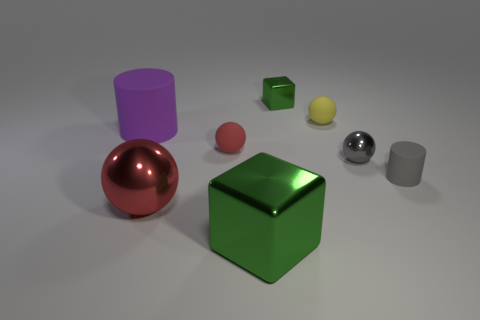Add 1 big red spheres. How many objects exist? 9 Subtract all cubes. How many objects are left? 6 Subtract 1 red spheres. How many objects are left? 7 Subtract all big rubber cylinders. Subtract all green metal cubes. How many objects are left? 5 Add 7 small yellow objects. How many small yellow objects are left? 8 Add 8 large purple matte spheres. How many large purple matte spheres exist? 8 